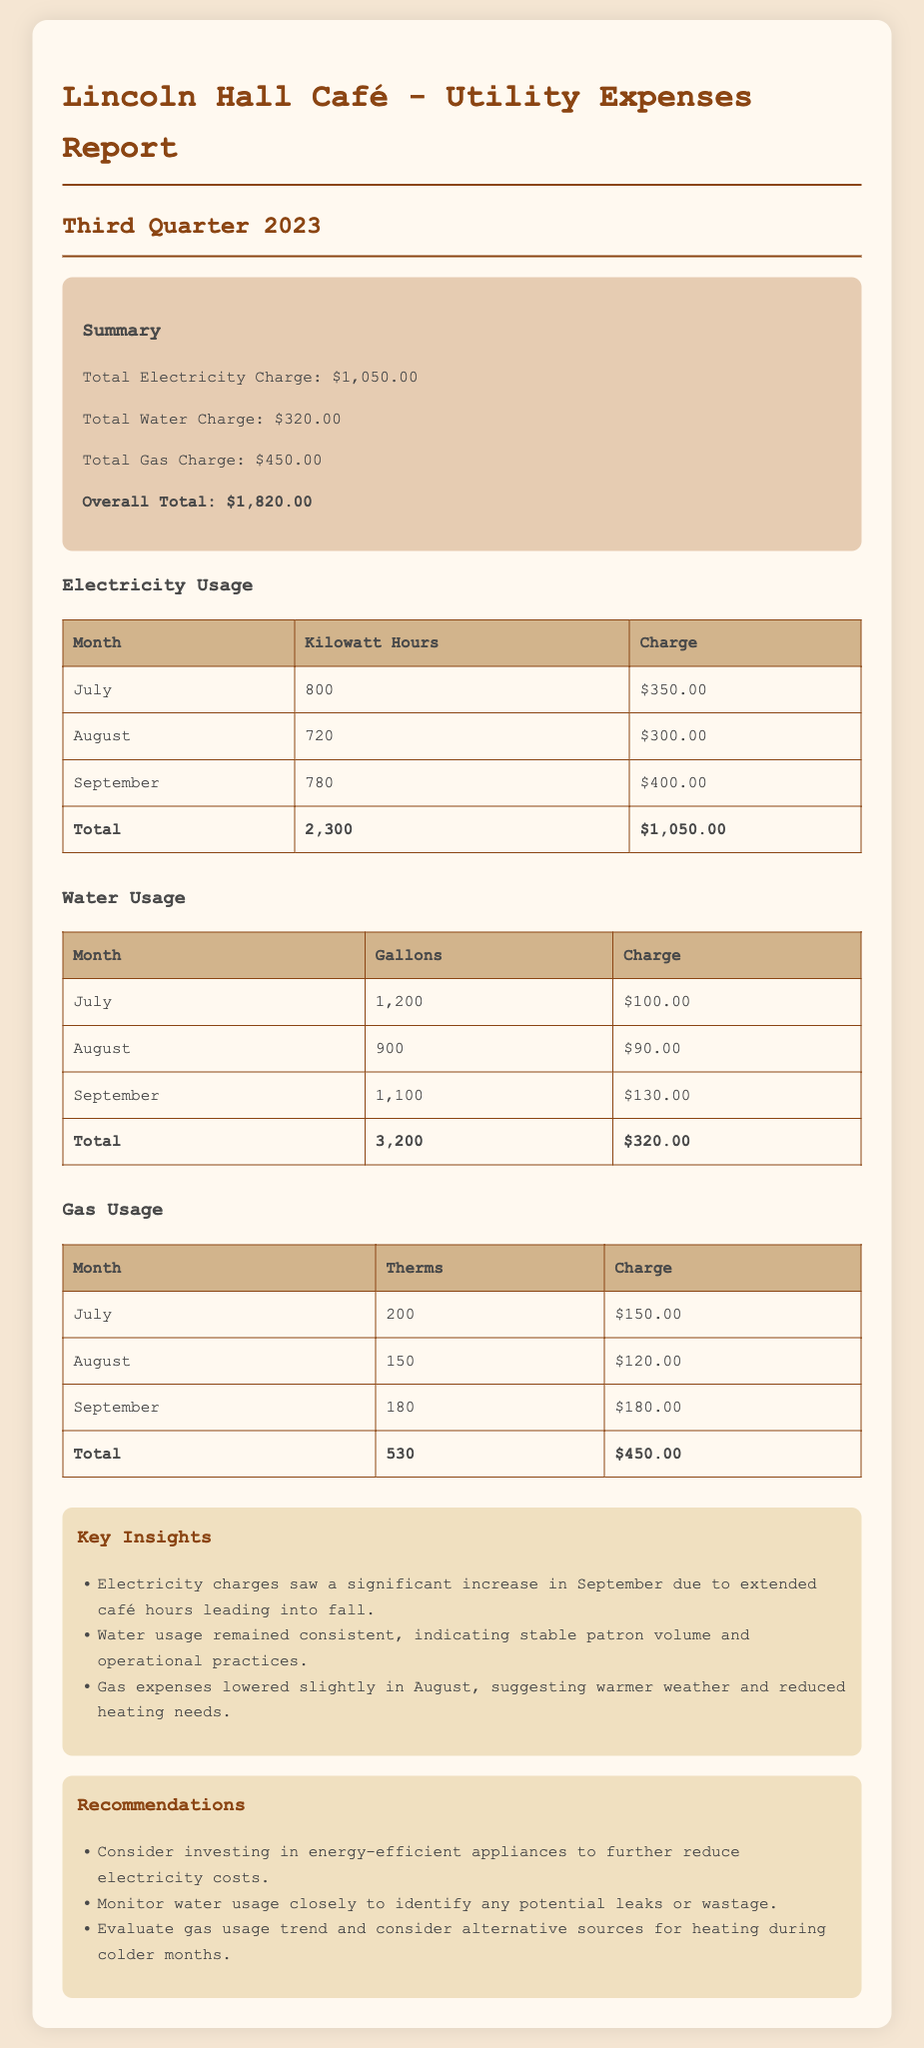What is the total electricity charge? The total electricity charge is directly mentioned in the summary of the report.
Answer: $1,050.00 How many gallons of water were used in August? The water usage section provides specific monthly usage, and for August it is listed.
Answer: 900 What was the gas charge for September? The gas usage section includes the charge for each month, and September's charge is specified.
Answer: $180.00 What is the overall total utility expense for the third quarter? The overall total is presented in the summary, combining charges from all utilities.
Answer: $1,820.00 What was the total electricity usage in kilowatt hours? The total electricity usage is calculated and shown in the electricity usage table.
Answer: 2,300 Which month had the highest water charge? The water usage table shows monthly charges, and based on this data, one can identify the month with the highest charge.
Answer: September What does the report suggest to reduce electricity costs? Recommendations section outlines potential strategies for cost reduction, specifically mentioned there.
Answer: Invest in energy-efficient appliances How many therms of gas were used in July? The gas usage table lists the therms consumed for July as provided.
Answer: 200 What was the trend observed in gas expenses during August? The insights section mentions a specific observation about the August gas expenses trend.
Answer: Lowered 